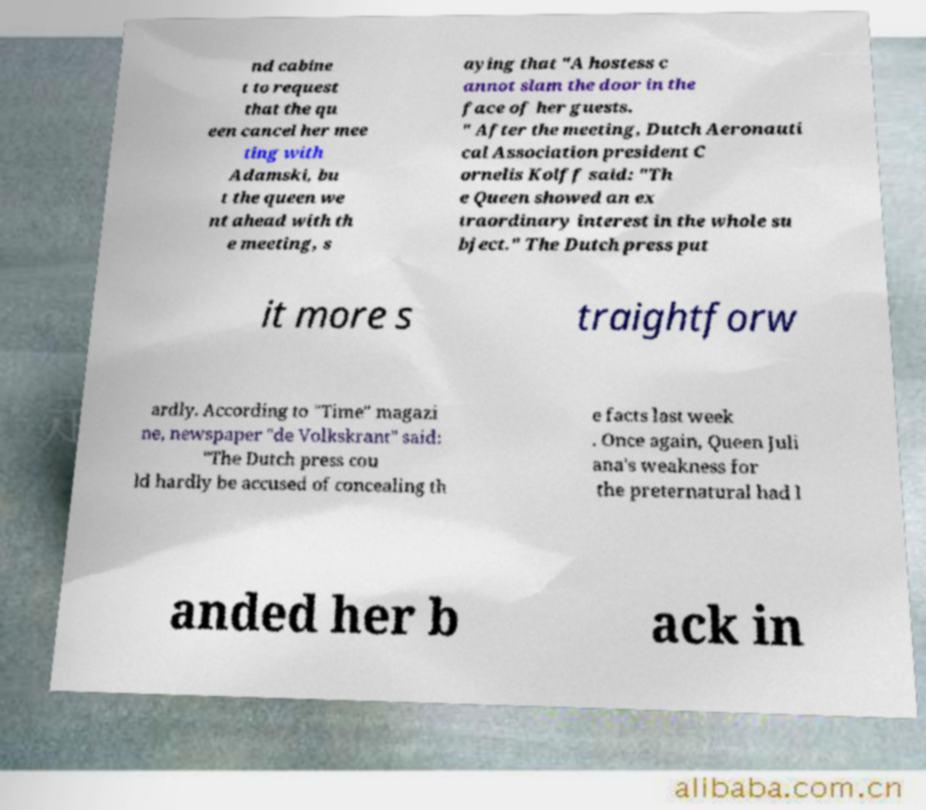For documentation purposes, I need the text within this image transcribed. Could you provide that? nd cabine t to request that the qu een cancel her mee ting with Adamski, bu t the queen we nt ahead with th e meeting, s aying that "A hostess c annot slam the door in the face of her guests. " After the meeting, Dutch Aeronauti cal Association president C ornelis Kolff said: "Th e Queen showed an ex traordinary interest in the whole su bject." The Dutch press put it more s traightforw ardly. According to "Time" magazi ne, newspaper "de Volkskrant" said: "The Dutch press cou ld hardly be accused of concealing th e facts last week . Once again, Queen Juli ana's weakness for the preternatural had l anded her b ack in 